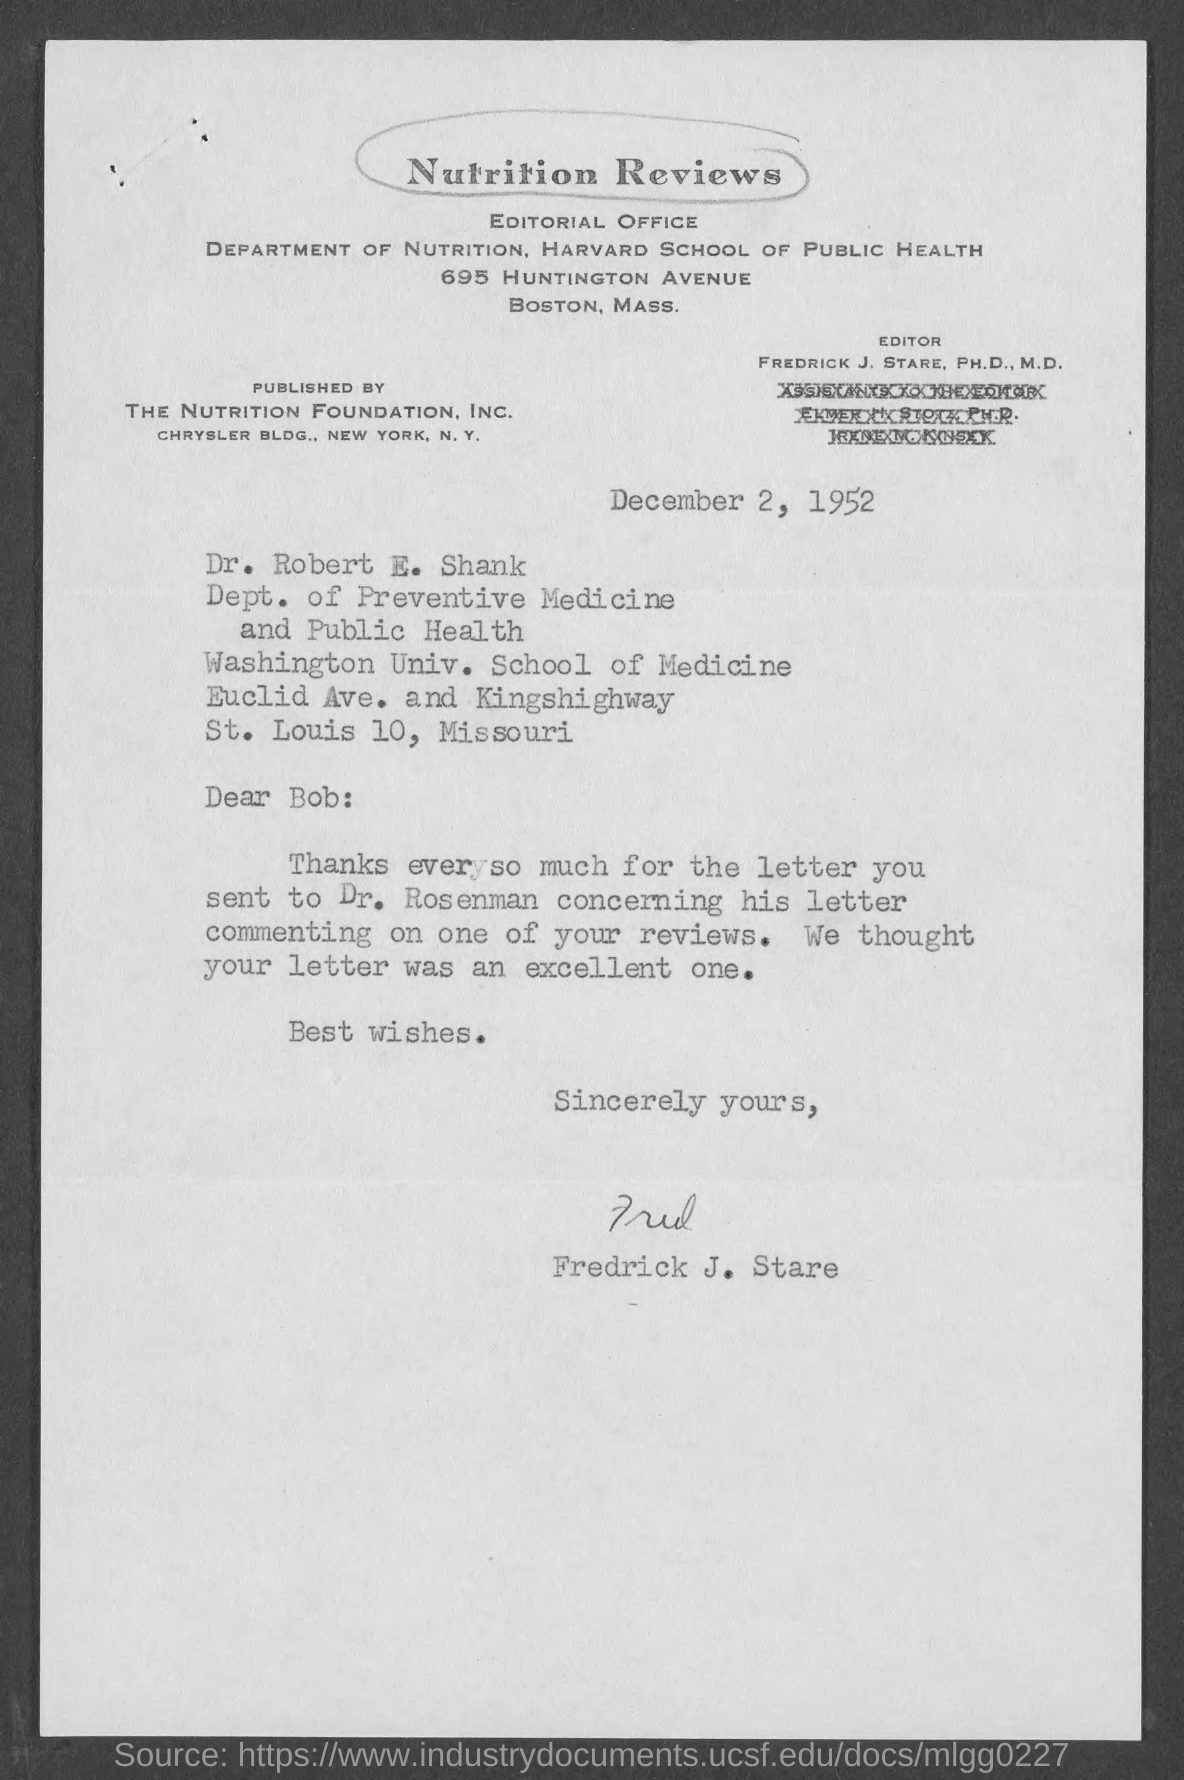What is the written in the top of the document ?
Your response must be concise. Nutrition Reviews. Who is the Editor ?
Make the answer very short. FREDRICK J. STARE, PH.D., M.D. When is the Memorandum dated on ?
Offer a very short reply. December 2, 1952. Who is the Memorandum from ?
Provide a succinct answer. Fredrick J. Stare. 